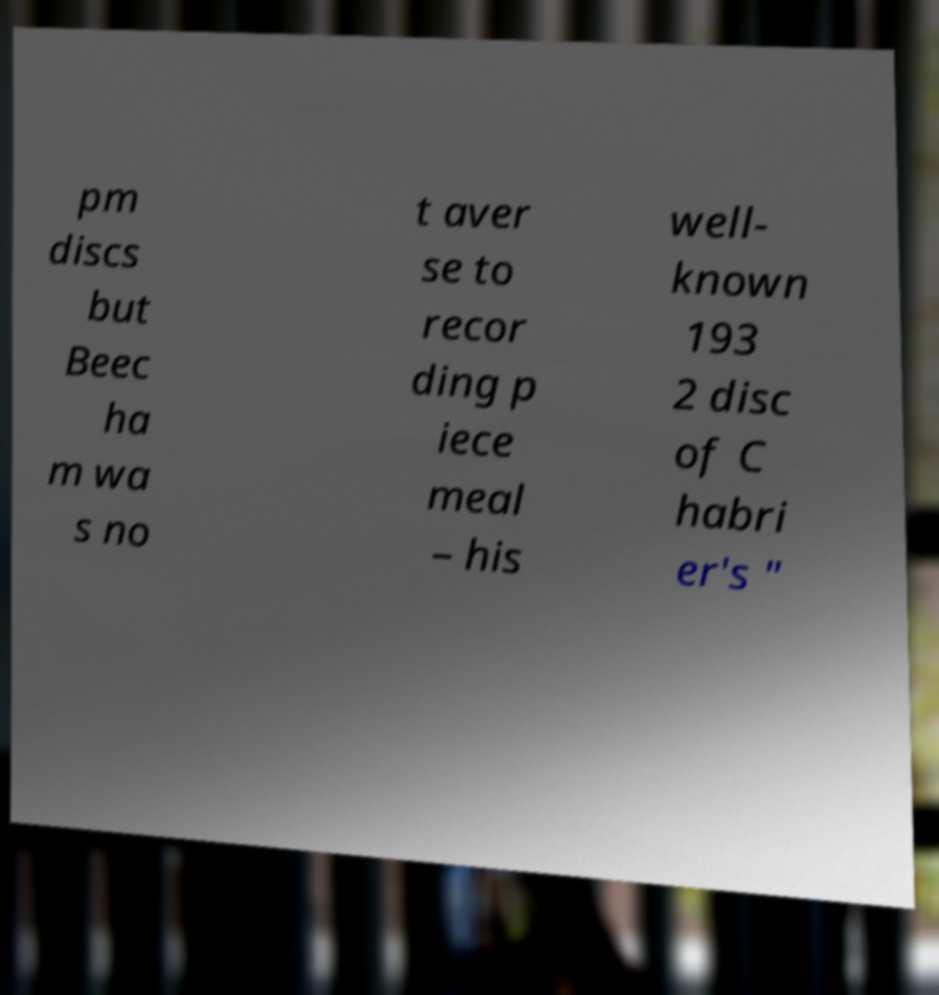Please identify and transcribe the text found in this image. pm discs but Beec ha m wa s no t aver se to recor ding p iece meal – his well- known 193 2 disc of C habri er's " 